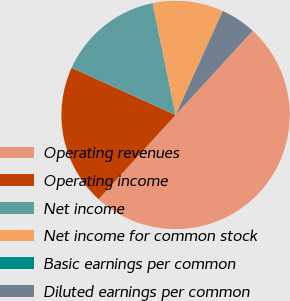<chart> <loc_0><loc_0><loc_500><loc_500><pie_chart><fcel>Operating revenues<fcel>Operating income<fcel>Net income<fcel>Net income for common stock<fcel>Basic earnings per common<fcel>Diluted earnings per common<nl><fcel>49.98%<fcel>20.0%<fcel>15.0%<fcel>10.0%<fcel>0.01%<fcel>5.01%<nl></chart> 